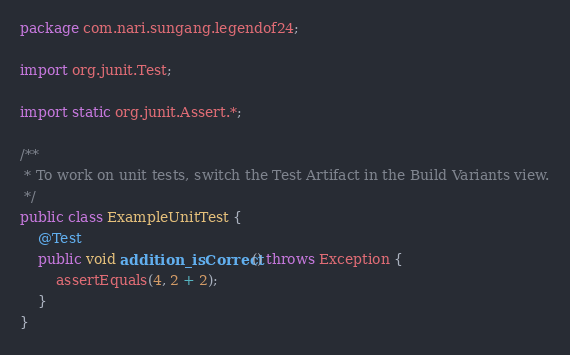Convert code to text. <code><loc_0><loc_0><loc_500><loc_500><_Java_>package com.nari.sungang.legendof24;

import org.junit.Test;

import static org.junit.Assert.*;

/**
 * To work on unit tests, switch the Test Artifact in the Build Variants view.
 */
public class ExampleUnitTest {
    @Test
    public void addition_isCorrect() throws Exception {
        assertEquals(4, 2 + 2);
    }
}</code> 